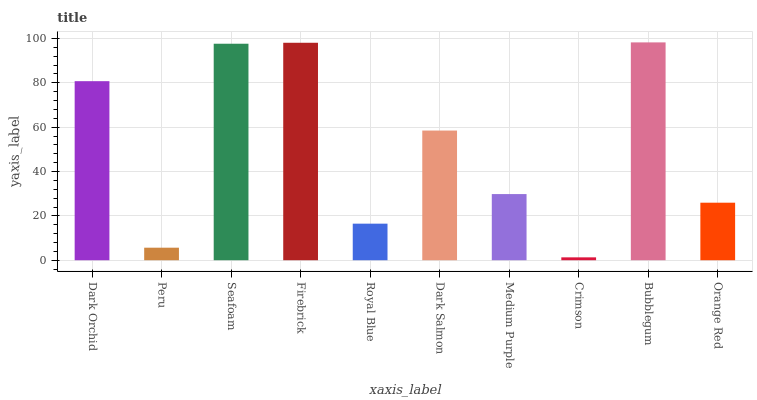Is Peru the minimum?
Answer yes or no. No. Is Peru the maximum?
Answer yes or no. No. Is Dark Orchid greater than Peru?
Answer yes or no. Yes. Is Peru less than Dark Orchid?
Answer yes or no. Yes. Is Peru greater than Dark Orchid?
Answer yes or no. No. Is Dark Orchid less than Peru?
Answer yes or no. No. Is Dark Salmon the high median?
Answer yes or no. Yes. Is Medium Purple the low median?
Answer yes or no. Yes. Is Royal Blue the high median?
Answer yes or no. No. Is Crimson the low median?
Answer yes or no. No. 